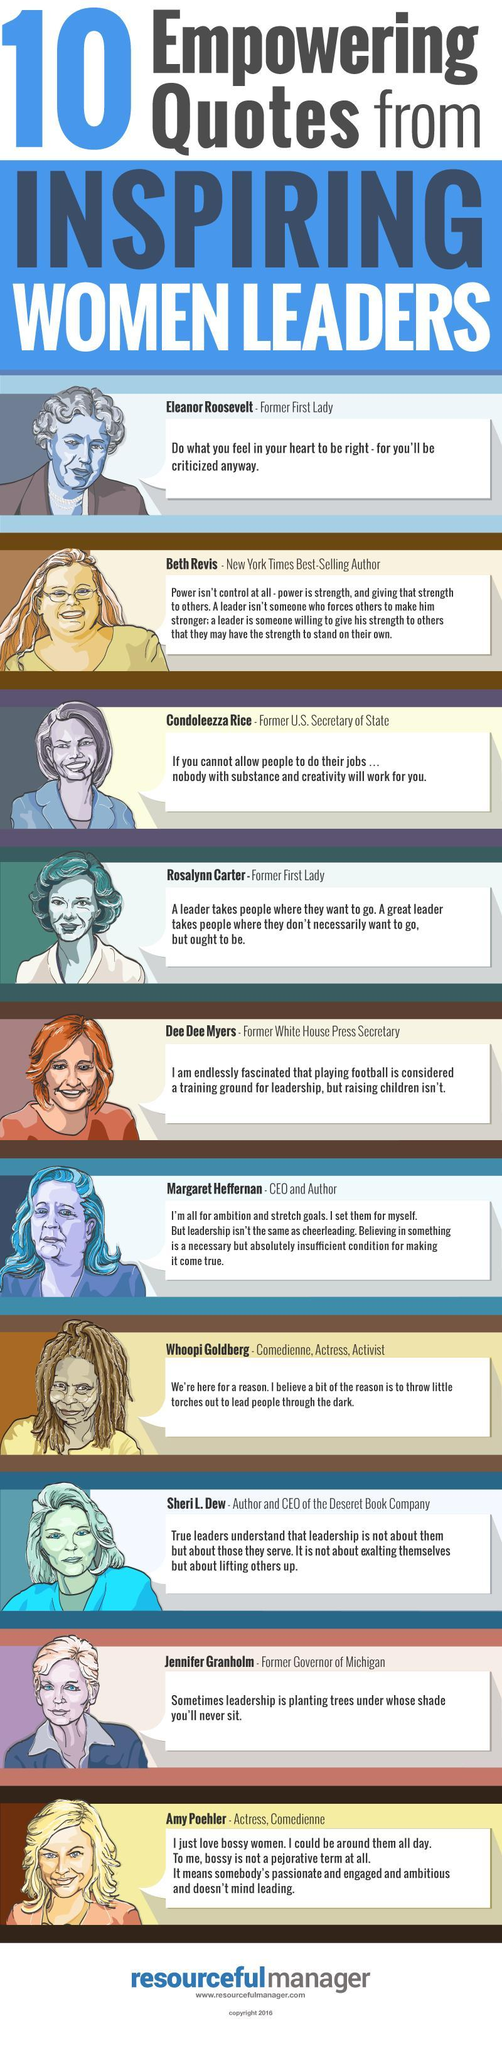Who are the two former first ladies mentioned in the list of women leaders?
Answer the question with a short phrase. Eleanor Roosevelt, Rosalynn Carter Who are the two prominent women comedians listed as women leaders? Whoopie Goldberg, Amy Poehler 